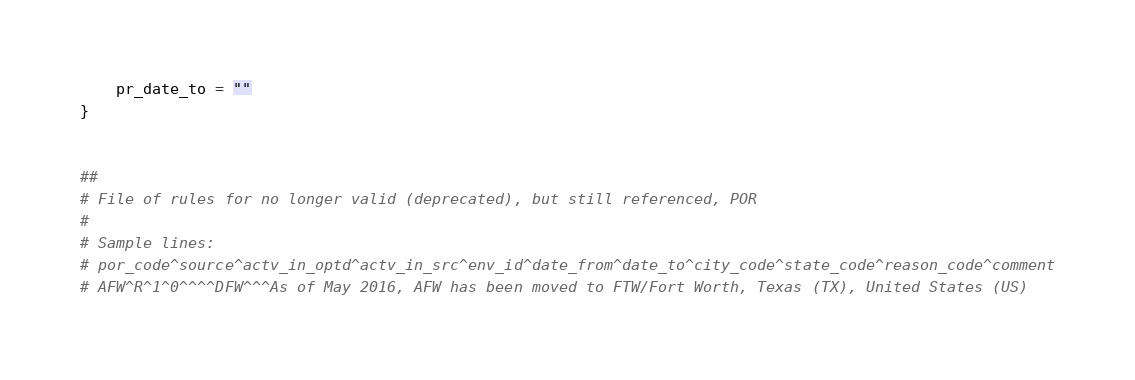Convert code to text. <code><loc_0><loc_0><loc_500><loc_500><_Awk_>    pr_date_to = ""
}


##
# File of rules for no longer valid (deprecated), but still referenced, POR
#
# Sample lines:
# por_code^source^actv_in_optd^actv_in_src^env_id^date_from^date_to^city_code^state_code^reason_code^comment
# AFW^R^1^0^^^^DFW^^^As of May 2016, AFW has been moved to FTW/Fort Worth, Texas (TX), United States (US)</code> 